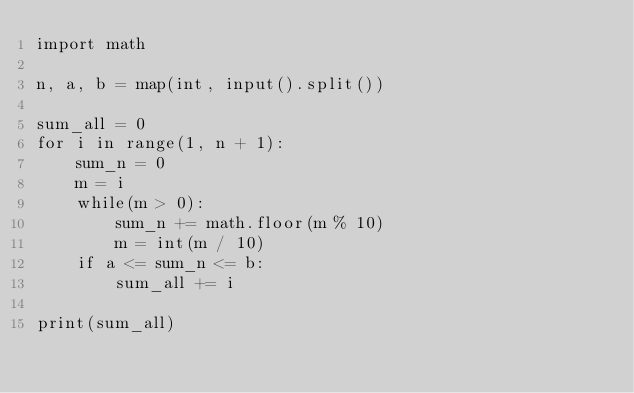Convert code to text. <code><loc_0><loc_0><loc_500><loc_500><_Python_>import math

n, a, b = map(int, input().split())

sum_all = 0
for i in range(1, n + 1):
    sum_n = 0
    m = i
    while(m > 0):
        sum_n += math.floor(m % 10)
        m = int(m / 10)
    if a <= sum_n <= b:
        sum_all += i

print(sum_all)</code> 